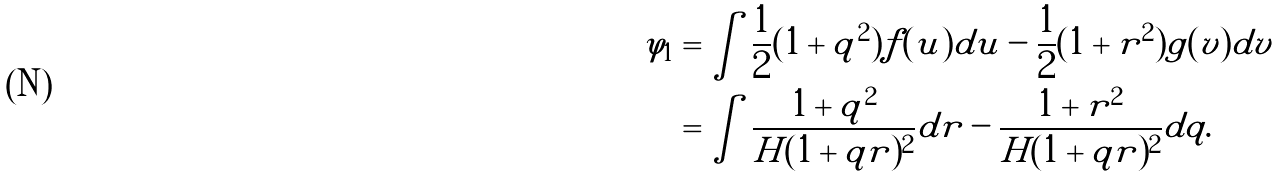Convert formula to latex. <formula><loc_0><loc_0><loc_500><loc_500>\varphi _ { 1 } & = \int \frac { 1 } { 2 } ( 1 + q ^ { 2 } ) f ( u ) d u - \frac { 1 } { 2 } ( 1 + r ^ { 2 } ) g ( v ) d v \\ & = \int \frac { 1 + q ^ { 2 } } { H ( 1 + q r ) ^ { 2 } } d r - \frac { 1 + r ^ { 2 } } { H ( 1 + q r ) ^ { 2 } } d q .</formula> 